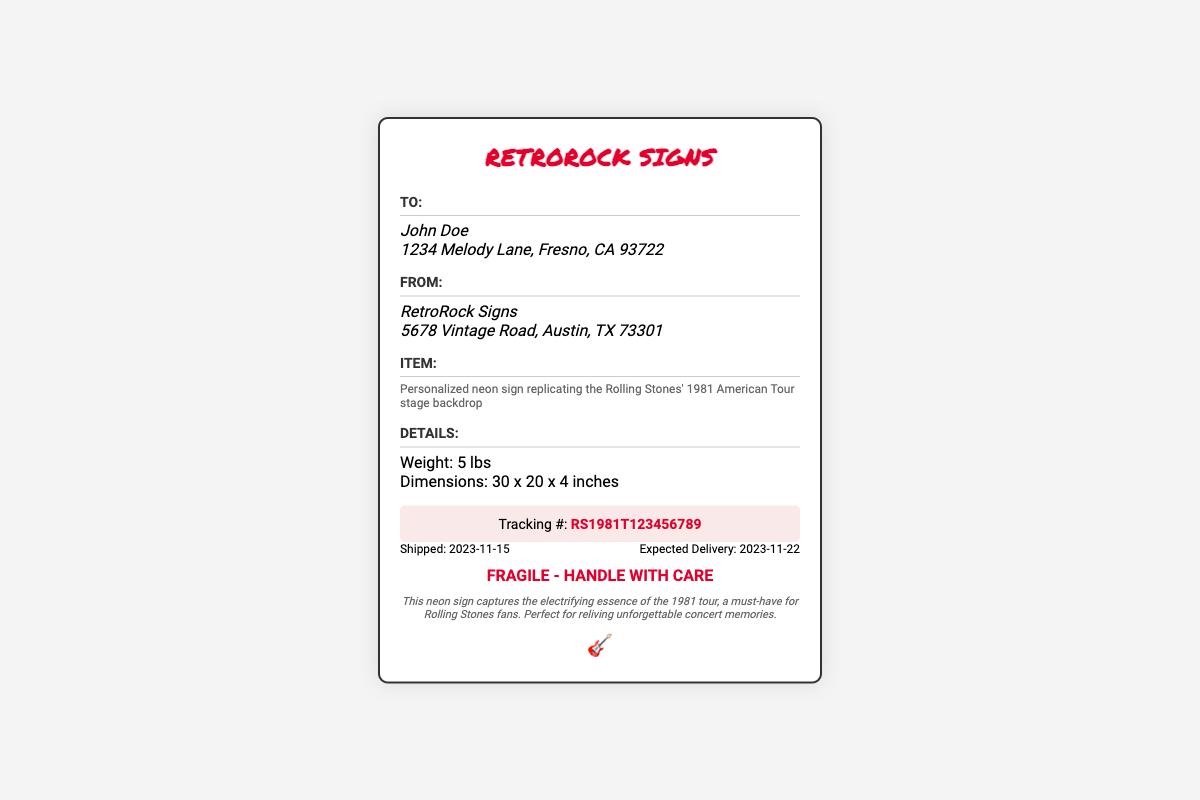What is the name of the recipient? The recipient's name is displayed under the "To:" section, which is John Doe.
Answer: John Doe What is the shipping weight of the item? The shipping weight is listed in the "Details:" section as 5 lbs.
Answer: 5 lbs What is the tracking number for this shipment? The tracking number is found in the "Tracking" section and is displayed prominently.
Answer: RS1981T123456789 What is the from address on the label? The "From:" section provides the address of the sender, which is RetroRock Signs, and the full address is included.
Answer: RetroRock Signs, 5678 Vintage Road, Austin, TX 73301 What is the expected delivery date? The expected delivery date is indicated in the "Dates" section of the label, showing when the item is expected to arrive.
Answer: 2023-11-22 What type of item is being shipped? The item description is provided under the "Item:" section, detailing what is being sent.
Answer: Personalized neon sign replicating the Rolling Stones' 1981 American Tour stage backdrop What is the handling instruction on the label? The "Handling" section explicitly states the instructions to be followed for this shipment.
Answer: Fragile - Handle with care What are the dimensions of the package? The dimensions are listed under the "Details:" section, providing size information about the shipping package.
Answer: 30 x 20 x 4 inches 